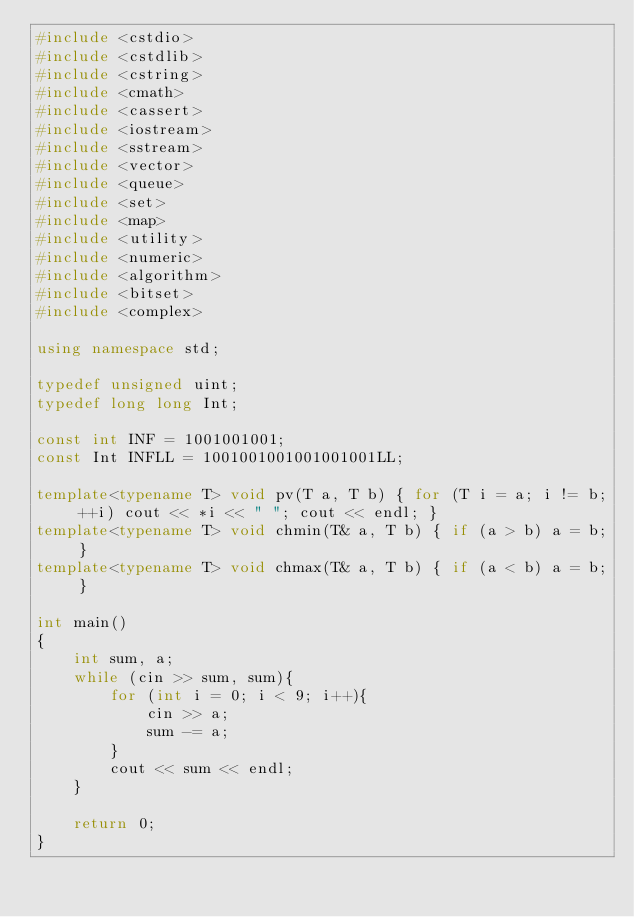<code> <loc_0><loc_0><loc_500><loc_500><_C++_>#include <cstdio>
#include <cstdlib>
#include <cstring>
#include <cmath>
#include <cassert>
#include <iostream>
#include <sstream>
#include <vector>
#include <queue>
#include <set>
#include <map>
#include <utility>
#include <numeric>
#include <algorithm>
#include <bitset>
#include <complex>

using namespace std;

typedef unsigned uint;
typedef long long Int;

const int INF = 1001001001;
const Int INFLL = 1001001001001001001LL;

template<typename T> void pv(T a, T b) { for (T i = a; i != b; ++i) cout << *i << " "; cout << endl; }
template<typename T> void chmin(T& a, T b) { if (a > b) a = b; }
template<typename T> void chmax(T& a, T b) { if (a < b) a = b; }

int main()
{
	int sum, a;
	while (cin >> sum, sum){
		for (int i = 0; i < 9; i++){
			cin >> a;
			sum -= a;
		}
		cout << sum << endl;
	}

    return 0;
}</code> 